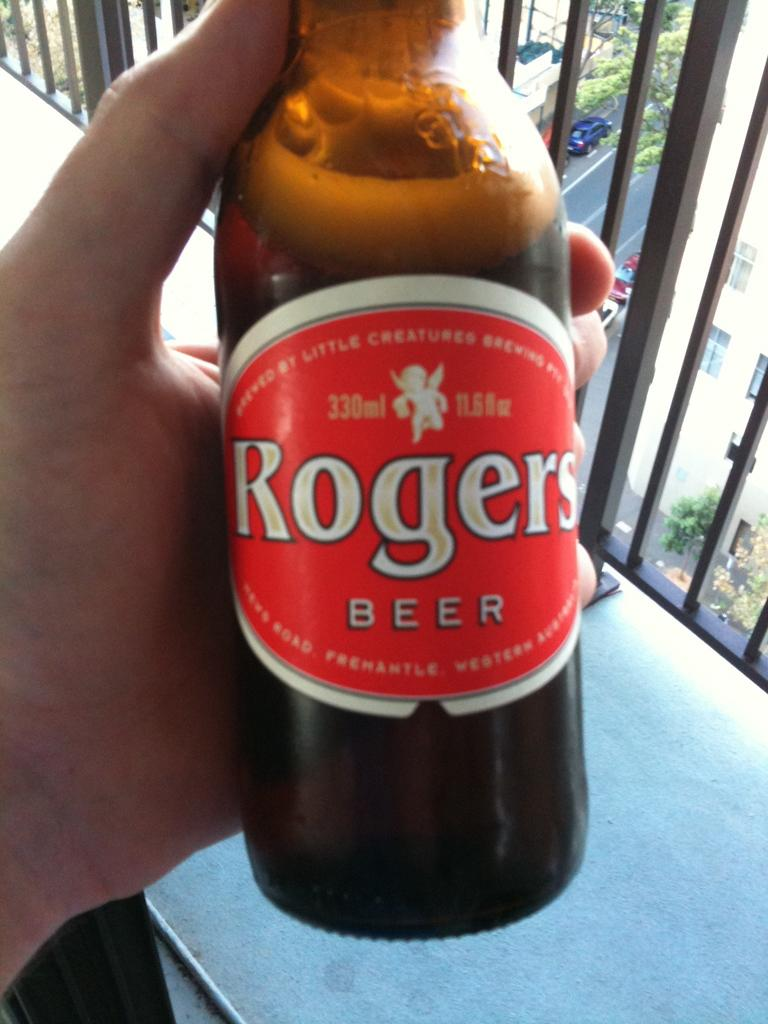<image>
Create a compact narrative representing the image presented. Rogers beer bottle being held by hand to take a photo 